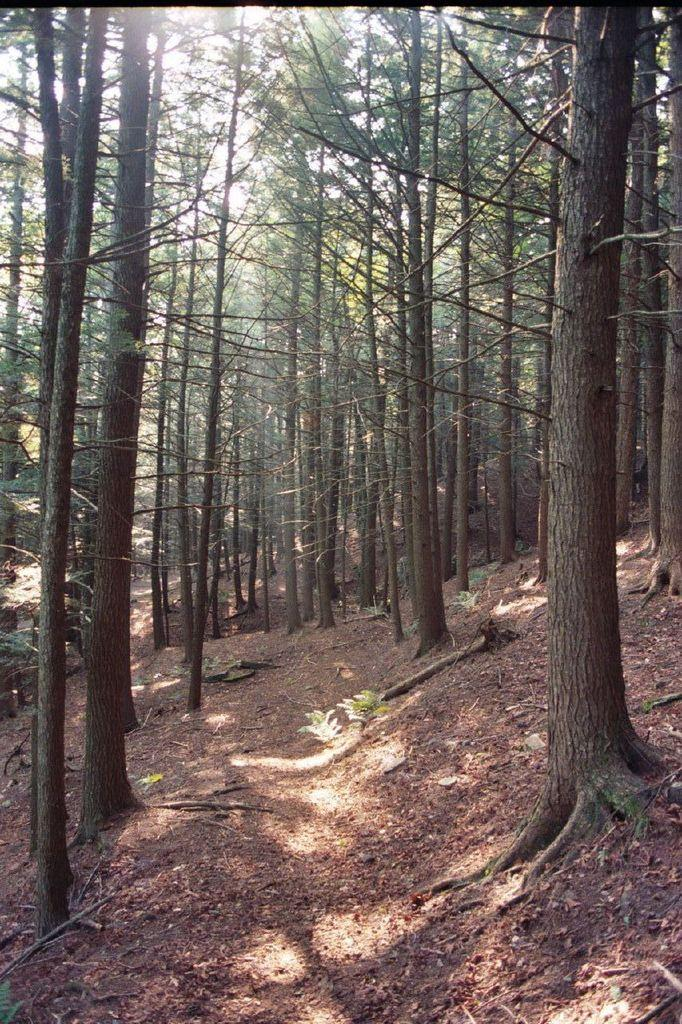What type of vegetation can be seen in the image? There are trees in the image. What color is the surprise on the canvas in the image? There is no surprise or canvas present in the image; it only features trees. 